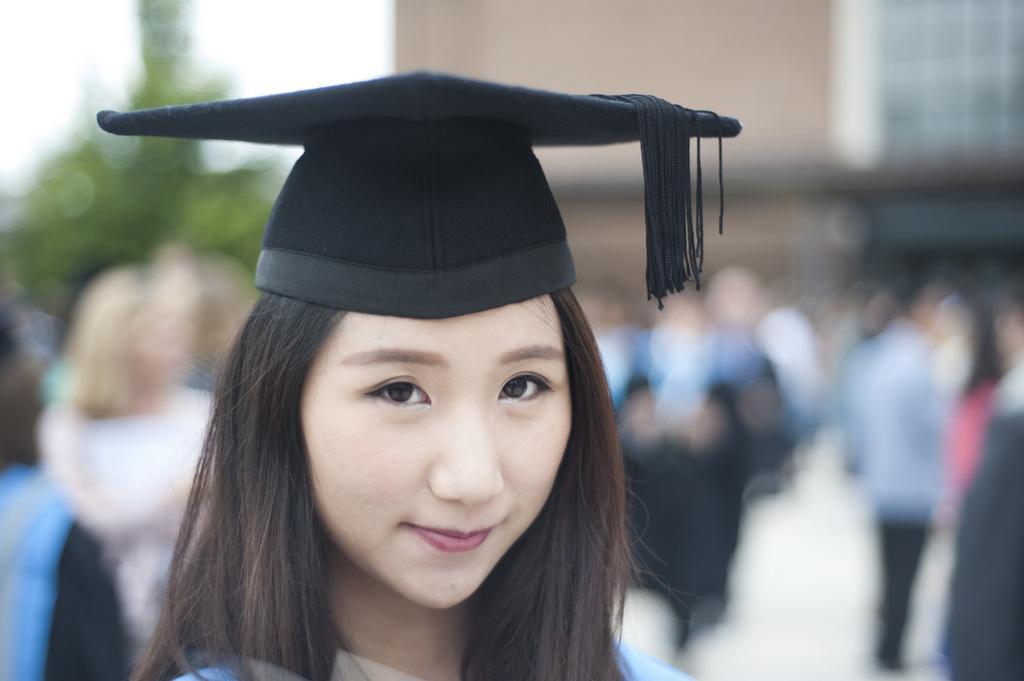Please provide a concise description of this image. Here in this picture we can see a woman wearing a cap on her and smiling present over there. 